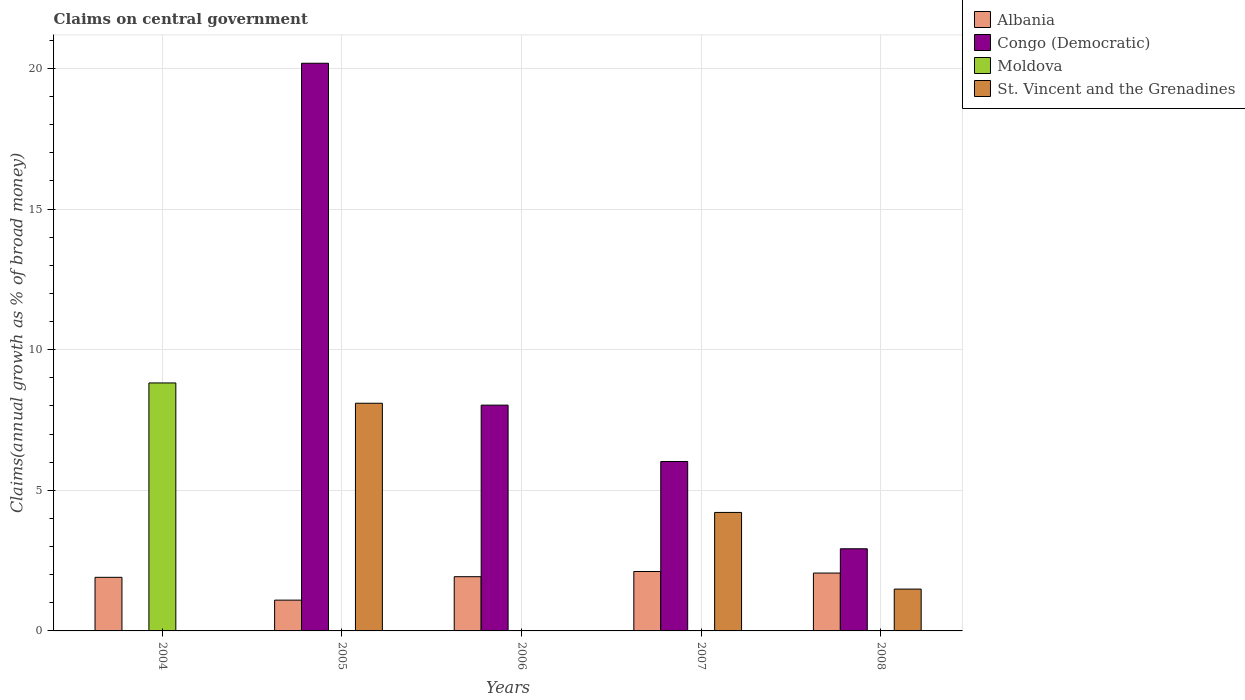How many groups of bars are there?
Offer a terse response. 5. Are the number of bars per tick equal to the number of legend labels?
Offer a very short reply. No. Are the number of bars on each tick of the X-axis equal?
Offer a terse response. No. How many bars are there on the 5th tick from the right?
Give a very brief answer. 2. Across all years, what is the maximum percentage of broad money claimed on centeral government in Moldova?
Keep it short and to the point. 8.82. In which year was the percentage of broad money claimed on centeral government in St. Vincent and the Grenadines maximum?
Your answer should be very brief. 2005. What is the total percentage of broad money claimed on centeral government in St. Vincent and the Grenadines in the graph?
Keep it short and to the point. 13.8. What is the difference between the percentage of broad money claimed on centeral government in Albania in 2007 and that in 2008?
Your response must be concise. 0.05. What is the difference between the percentage of broad money claimed on centeral government in Congo (Democratic) in 2008 and the percentage of broad money claimed on centeral government in St. Vincent and the Grenadines in 2005?
Ensure brevity in your answer.  -5.17. What is the average percentage of broad money claimed on centeral government in Congo (Democratic) per year?
Your answer should be very brief. 7.43. In the year 2006, what is the difference between the percentage of broad money claimed on centeral government in Congo (Democratic) and percentage of broad money claimed on centeral government in Albania?
Ensure brevity in your answer.  6.1. In how many years, is the percentage of broad money claimed on centeral government in Albania greater than 16 %?
Your answer should be very brief. 0. What is the ratio of the percentage of broad money claimed on centeral government in Albania in 2004 to that in 2008?
Your response must be concise. 0.93. What is the difference between the highest and the second highest percentage of broad money claimed on centeral government in St. Vincent and the Grenadines?
Provide a short and direct response. 3.88. What is the difference between the highest and the lowest percentage of broad money claimed on centeral government in St. Vincent and the Grenadines?
Give a very brief answer. 8.1. How many bars are there?
Make the answer very short. 13. Are the values on the major ticks of Y-axis written in scientific E-notation?
Provide a succinct answer. No. How are the legend labels stacked?
Ensure brevity in your answer.  Vertical. What is the title of the graph?
Offer a very short reply. Claims on central government. Does "Liechtenstein" appear as one of the legend labels in the graph?
Keep it short and to the point. No. What is the label or title of the X-axis?
Give a very brief answer. Years. What is the label or title of the Y-axis?
Make the answer very short. Claims(annual growth as % of broad money). What is the Claims(annual growth as % of broad money) in Albania in 2004?
Make the answer very short. 1.91. What is the Claims(annual growth as % of broad money) in Congo (Democratic) in 2004?
Your answer should be compact. 0. What is the Claims(annual growth as % of broad money) of Moldova in 2004?
Keep it short and to the point. 8.82. What is the Claims(annual growth as % of broad money) of St. Vincent and the Grenadines in 2004?
Keep it short and to the point. 0. What is the Claims(annual growth as % of broad money) in Albania in 2005?
Provide a short and direct response. 1.09. What is the Claims(annual growth as % of broad money) in Congo (Democratic) in 2005?
Ensure brevity in your answer.  20.18. What is the Claims(annual growth as % of broad money) in St. Vincent and the Grenadines in 2005?
Provide a short and direct response. 8.1. What is the Claims(annual growth as % of broad money) in Albania in 2006?
Keep it short and to the point. 1.93. What is the Claims(annual growth as % of broad money) in Congo (Democratic) in 2006?
Your answer should be very brief. 8.03. What is the Claims(annual growth as % of broad money) in St. Vincent and the Grenadines in 2006?
Ensure brevity in your answer.  0. What is the Claims(annual growth as % of broad money) of Albania in 2007?
Give a very brief answer. 2.11. What is the Claims(annual growth as % of broad money) of Congo (Democratic) in 2007?
Your response must be concise. 6.02. What is the Claims(annual growth as % of broad money) of Moldova in 2007?
Your answer should be compact. 0. What is the Claims(annual growth as % of broad money) in St. Vincent and the Grenadines in 2007?
Keep it short and to the point. 4.21. What is the Claims(annual growth as % of broad money) of Albania in 2008?
Your answer should be very brief. 2.06. What is the Claims(annual growth as % of broad money) of Congo (Democratic) in 2008?
Your answer should be compact. 2.92. What is the Claims(annual growth as % of broad money) in St. Vincent and the Grenadines in 2008?
Keep it short and to the point. 1.49. Across all years, what is the maximum Claims(annual growth as % of broad money) in Albania?
Give a very brief answer. 2.11. Across all years, what is the maximum Claims(annual growth as % of broad money) in Congo (Democratic)?
Ensure brevity in your answer.  20.18. Across all years, what is the maximum Claims(annual growth as % of broad money) in Moldova?
Keep it short and to the point. 8.82. Across all years, what is the maximum Claims(annual growth as % of broad money) in St. Vincent and the Grenadines?
Your answer should be compact. 8.1. Across all years, what is the minimum Claims(annual growth as % of broad money) of Albania?
Give a very brief answer. 1.09. Across all years, what is the minimum Claims(annual growth as % of broad money) of Moldova?
Make the answer very short. 0. Across all years, what is the minimum Claims(annual growth as % of broad money) in St. Vincent and the Grenadines?
Offer a terse response. 0. What is the total Claims(annual growth as % of broad money) of Albania in the graph?
Make the answer very short. 9.1. What is the total Claims(annual growth as % of broad money) in Congo (Democratic) in the graph?
Your response must be concise. 37.16. What is the total Claims(annual growth as % of broad money) in Moldova in the graph?
Offer a very short reply. 8.82. What is the total Claims(annual growth as % of broad money) of St. Vincent and the Grenadines in the graph?
Keep it short and to the point. 13.8. What is the difference between the Claims(annual growth as % of broad money) in Albania in 2004 and that in 2005?
Your answer should be compact. 0.81. What is the difference between the Claims(annual growth as % of broad money) in Albania in 2004 and that in 2006?
Keep it short and to the point. -0.02. What is the difference between the Claims(annual growth as % of broad money) in Albania in 2004 and that in 2007?
Offer a very short reply. -0.21. What is the difference between the Claims(annual growth as % of broad money) of Albania in 2004 and that in 2008?
Provide a short and direct response. -0.15. What is the difference between the Claims(annual growth as % of broad money) in Albania in 2005 and that in 2006?
Your answer should be very brief. -0.83. What is the difference between the Claims(annual growth as % of broad money) in Congo (Democratic) in 2005 and that in 2006?
Provide a short and direct response. 12.16. What is the difference between the Claims(annual growth as % of broad money) in Albania in 2005 and that in 2007?
Provide a succinct answer. -1.02. What is the difference between the Claims(annual growth as % of broad money) in Congo (Democratic) in 2005 and that in 2007?
Your response must be concise. 14.16. What is the difference between the Claims(annual growth as % of broad money) of St. Vincent and the Grenadines in 2005 and that in 2007?
Provide a succinct answer. 3.88. What is the difference between the Claims(annual growth as % of broad money) in Albania in 2005 and that in 2008?
Make the answer very short. -0.96. What is the difference between the Claims(annual growth as % of broad money) in Congo (Democratic) in 2005 and that in 2008?
Offer a terse response. 17.26. What is the difference between the Claims(annual growth as % of broad money) of St. Vincent and the Grenadines in 2005 and that in 2008?
Provide a succinct answer. 6.61. What is the difference between the Claims(annual growth as % of broad money) in Albania in 2006 and that in 2007?
Make the answer very short. -0.18. What is the difference between the Claims(annual growth as % of broad money) of Congo (Democratic) in 2006 and that in 2007?
Ensure brevity in your answer.  2. What is the difference between the Claims(annual growth as % of broad money) in Albania in 2006 and that in 2008?
Provide a short and direct response. -0.13. What is the difference between the Claims(annual growth as % of broad money) in Congo (Democratic) in 2006 and that in 2008?
Provide a short and direct response. 5.11. What is the difference between the Claims(annual growth as % of broad money) in Albania in 2007 and that in 2008?
Keep it short and to the point. 0.06. What is the difference between the Claims(annual growth as % of broad money) of Congo (Democratic) in 2007 and that in 2008?
Give a very brief answer. 3.1. What is the difference between the Claims(annual growth as % of broad money) in St. Vincent and the Grenadines in 2007 and that in 2008?
Offer a very short reply. 2.73. What is the difference between the Claims(annual growth as % of broad money) of Albania in 2004 and the Claims(annual growth as % of broad money) of Congo (Democratic) in 2005?
Your response must be concise. -18.28. What is the difference between the Claims(annual growth as % of broad money) of Albania in 2004 and the Claims(annual growth as % of broad money) of St. Vincent and the Grenadines in 2005?
Give a very brief answer. -6.19. What is the difference between the Claims(annual growth as % of broad money) of Moldova in 2004 and the Claims(annual growth as % of broad money) of St. Vincent and the Grenadines in 2005?
Offer a very short reply. 0.72. What is the difference between the Claims(annual growth as % of broad money) of Albania in 2004 and the Claims(annual growth as % of broad money) of Congo (Democratic) in 2006?
Your response must be concise. -6.12. What is the difference between the Claims(annual growth as % of broad money) of Albania in 2004 and the Claims(annual growth as % of broad money) of Congo (Democratic) in 2007?
Make the answer very short. -4.12. What is the difference between the Claims(annual growth as % of broad money) of Albania in 2004 and the Claims(annual growth as % of broad money) of St. Vincent and the Grenadines in 2007?
Give a very brief answer. -2.31. What is the difference between the Claims(annual growth as % of broad money) in Moldova in 2004 and the Claims(annual growth as % of broad money) in St. Vincent and the Grenadines in 2007?
Keep it short and to the point. 4.6. What is the difference between the Claims(annual growth as % of broad money) in Albania in 2004 and the Claims(annual growth as % of broad money) in Congo (Democratic) in 2008?
Ensure brevity in your answer.  -1.01. What is the difference between the Claims(annual growth as % of broad money) of Albania in 2004 and the Claims(annual growth as % of broad money) of St. Vincent and the Grenadines in 2008?
Your response must be concise. 0.42. What is the difference between the Claims(annual growth as % of broad money) of Moldova in 2004 and the Claims(annual growth as % of broad money) of St. Vincent and the Grenadines in 2008?
Your response must be concise. 7.33. What is the difference between the Claims(annual growth as % of broad money) in Albania in 2005 and the Claims(annual growth as % of broad money) in Congo (Democratic) in 2006?
Provide a succinct answer. -6.93. What is the difference between the Claims(annual growth as % of broad money) in Albania in 2005 and the Claims(annual growth as % of broad money) in Congo (Democratic) in 2007?
Your response must be concise. -4.93. What is the difference between the Claims(annual growth as % of broad money) in Albania in 2005 and the Claims(annual growth as % of broad money) in St. Vincent and the Grenadines in 2007?
Offer a very short reply. -3.12. What is the difference between the Claims(annual growth as % of broad money) in Congo (Democratic) in 2005 and the Claims(annual growth as % of broad money) in St. Vincent and the Grenadines in 2007?
Ensure brevity in your answer.  15.97. What is the difference between the Claims(annual growth as % of broad money) of Albania in 2005 and the Claims(annual growth as % of broad money) of Congo (Democratic) in 2008?
Your answer should be very brief. -1.83. What is the difference between the Claims(annual growth as % of broad money) of Albania in 2005 and the Claims(annual growth as % of broad money) of St. Vincent and the Grenadines in 2008?
Provide a succinct answer. -0.39. What is the difference between the Claims(annual growth as % of broad money) of Congo (Democratic) in 2005 and the Claims(annual growth as % of broad money) of St. Vincent and the Grenadines in 2008?
Offer a very short reply. 18.7. What is the difference between the Claims(annual growth as % of broad money) in Albania in 2006 and the Claims(annual growth as % of broad money) in Congo (Democratic) in 2007?
Keep it short and to the point. -4.1. What is the difference between the Claims(annual growth as % of broad money) in Albania in 2006 and the Claims(annual growth as % of broad money) in St. Vincent and the Grenadines in 2007?
Your answer should be very brief. -2.28. What is the difference between the Claims(annual growth as % of broad money) of Congo (Democratic) in 2006 and the Claims(annual growth as % of broad money) of St. Vincent and the Grenadines in 2007?
Your answer should be very brief. 3.82. What is the difference between the Claims(annual growth as % of broad money) of Albania in 2006 and the Claims(annual growth as % of broad money) of Congo (Democratic) in 2008?
Offer a very short reply. -0.99. What is the difference between the Claims(annual growth as % of broad money) in Albania in 2006 and the Claims(annual growth as % of broad money) in St. Vincent and the Grenadines in 2008?
Keep it short and to the point. 0.44. What is the difference between the Claims(annual growth as % of broad money) of Congo (Democratic) in 2006 and the Claims(annual growth as % of broad money) of St. Vincent and the Grenadines in 2008?
Make the answer very short. 6.54. What is the difference between the Claims(annual growth as % of broad money) of Albania in 2007 and the Claims(annual growth as % of broad money) of Congo (Democratic) in 2008?
Ensure brevity in your answer.  -0.81. What is the difference between the Claims(annual growth as % of broad money) of Albania in 2007 and the Claims(annual growth as % of broad money) of St. Vincent and the Grenadines in 2008?
Provide a short and direct response. 0.63. What is the difference between the Claims(annual growth as % of broad money) in Congo (Democratic) in 2007 and the Claims(annual growth as % of broad money) in St. Vincent and the Grenadines in 2008?
Make the answer very short. 4.54. What is the average Claims(annual growth as % of broad money) of Albania per year?
Provide a succinct answer. 1.82. What is the average Claims(annual growth as % of broad money) of Congo (Democratic) per year?
Provide a short and direct response. 7.43. What is the average Claims(annual growth as % of broad money) in Moldova per year?
Keep it short and to the point. 1.76. What is the average Claims(annual growth as % of broad money) of St. Vincent and the Grenadines per year?
Your answer should be compact. 2.76. In the year 2004, what is the difference between the Claims(annual growth as % of broad money) of Albania and Claims(annual growth as % of broad money) of Moldova?
Give a very brief answer. -6.91. In the year 2005, what is the difference between the Claims(annual growth as % of broad money) of Albania and Claims(annual growth as % of broad money) of Congo (Democratic)?
Your answer should be compact. -19.09. In the year 2005, what is the difference between the Claims(annual growth as % of broad money) of Albania and Claims(annual growth as % of broad money) of St. Vincent and the Grenadines?
Your answer should be very brief. -7. In the year 2005, what is the difference between the Claims(annual growth as % of broad money) of Congo (Democratic) and Claims(annual growth as % of broad money) of St. Vincent and the Grenadines?
Keep it short and to the point. 12.09. In the year 2007, what is the difference between the Claims(annual growth as % of broad money) in Albania and Claims(annual growth as % of broad money) in Congo (Democratic)?
Keep it short and to the point. -3.91. In the year 2007, what is the difference between the Claims(annual growth as % of broad money) in Albania and Claims(annual growth as % of broad money) in St. Vincent and the Grenadines?
Ensure brevity in your answer.  -2.1. In the year 2007, what is the difference between the Claims(annual growth as % of broad money) of Congo (Democratic) and Claims(annual growth as % of broad money) of St. Vincent and the Grenadines?
Keep it short and to the point. 1.81. In the year 2008, what is the difference between the Claims(annual growth as % of broad money) of Albania and Claims(annual growth as % of broad money) of Congo (Democratic)?
Your response must be concise. -0.86. In the year 2008, what is the difference between the Claims(annual growth as % of broad money) in Albania and Claims(annual growth as % of broad money) in St. Vincent and the Grenadines?
Make the answer very short. 0.57. In the year 2008, what is the difference between the Claims(annual growth as % of broad money) of Congo (Democratic) and Claims(annual growth as % of broad money) of St. Vincent and the Grenadines?
Your response must be concise. 1.43. What is the ratio of the Claims(annual growth as % of broad money) of Albania in 2004 to that in 2005?
Provide a short and direct response. 1.74. What is the ratio of the Claims(annual growth as % of broad money) of Albania in 2004 to that in 2007?
Your response must be concise. 0.9. What is the ratio of the Claims(annual growth as % of broad money) of Albania in 2004 to that in 2008?
Your answer should be compact. 0.93. What is the ratio of the Claims(annual growth as % of broad money) in Albania in 2005 to that in 2006?
Keep it short and to the point. 0.57. What is the ratio of the Claims(annual growth as % of broad money) in Congo (Democratic) in 2005 to that in 2006?
Your answer should be very brief. 2.51. What is the ratio of the Claims(annual growth as % of broad money) of Albania in 2005 to that in 2007?
Your answer should be very brief. 0.52. What is the ratio of the Claims(annual growth as % of broad money) of Congo (Democratic) in 2005 to that in 2007?
Provide a short and direct response. 3.35. What is the ratio of the Claims(annual growth as % of broad money) in St. Vincent and the Grenadines in 2005 to that in 2007?
Provide a succinct answer. 1.92. What is the ratio of the Claims(annual growth as % of broad money) in Albania in 2005 to that in 2008?
Provide a short and direct response. 0.53. What is the ratio of the Claims(annual growth as % of broad money) of Congo (Democratic) in 2005 to that in 2008?
Your response must be concise. 6.91. What is the ratio of the Claims(annual growth as % of broad money) in St. Vincent and the Grenadines in 2005 to that in 2008?
Provide a short and direct response. 5.44. What is the ratio of the Claims(annual growth as % of broad money) of Albania in 2006 to that in 2007?
Provide a short and direct response. 0.91. What is the ratio of the Claims(annual growth as % of broad money) in Congo (Democratic) in 2006 to that in 2007?
Make the answer very short. 1.33. What is the ratio of the Claims(annual growth as % of broad money) in Albania in 2006 to that in 2008?
Make the answer very short. 0.94. What is the ratio of the Claims(annual growth as % of broad money) of Congo (Democratic) in 2006 to that in 2008?
Offer a terse response. 2.75. What is the ratio of the Claims(annual growth as % of broad money) in Albania in 2007 to that in 2008?
Your response must be concise. 1.03. What is the ratio of the Claims(annual growth as % of broad money) in Congo (Democratic) in 2007 to that in 2008?
Your answer should be very brief. 2.06. What is the ratio of the Claims(annual growth as % of broad money) in St. Vincent and the Grenadines in 2007 to that in 2008?
Your answer should be compact. 2.83. What is the difference between the highest and the second highest Claims(annual growth as % of broad money) in Albania?
Offer a terse response. 0.06. What is the difference between the highest and the second highest Claims(annual growth as % of broad money) in Congo (Democratic)?
Offer a very short reply. 12.16. What is the difference between the highest and the second highest Claims(annual growth as % of broad money) in St. Vincent and the Grenadines?
Provide a succinct answer. 3.88. What is the difference between the highest and the lowest Claims(annual growth as % of broad money) of Albania?
Offer a terse response. 1.02. What is the difference between the highest and the lowest Claims(annual growth as % of broad money) in Congo (Democratic)?
Your response must be concise. 20.18. What is the difference between the highest and the lowest Claims(annual growth as % of broad money) of Moldova?
Offer a terse response. 8.82. What is the difference between the highest and the lowest Claims(annual growth as % of broad money) in St. Vincent and the Grenadines?
Ensure brevity in your answer.  8.1. 